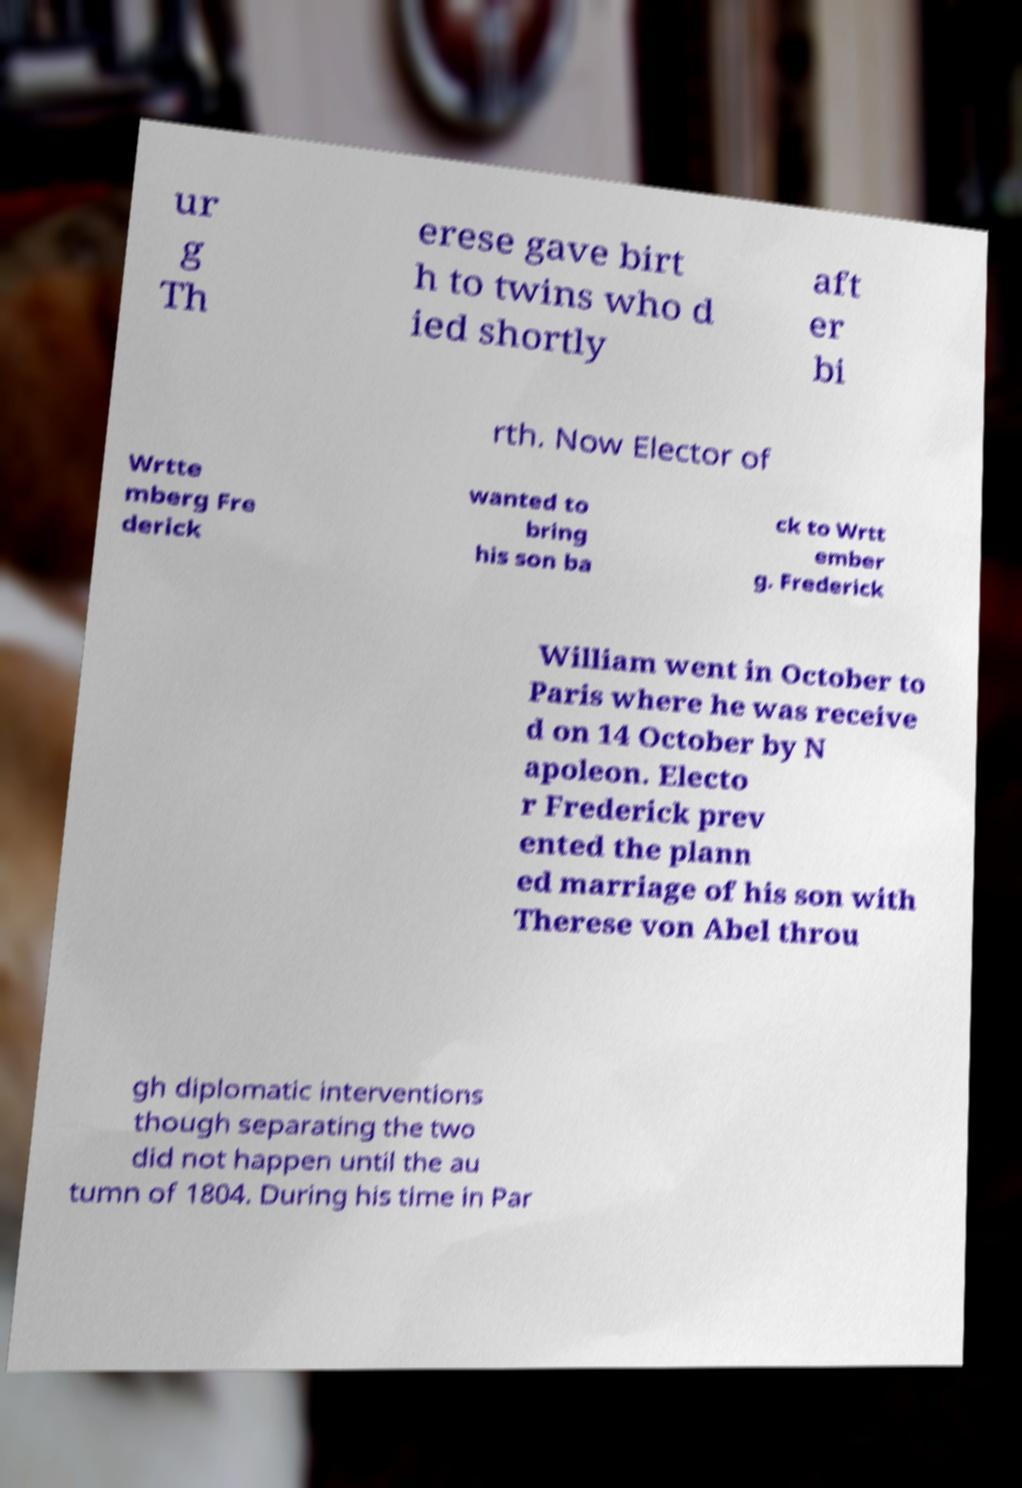Can you read and provide the text displayed in the image?This photo seems to have some interesting text. Can you extract and type it out for me? ur g Th erese gave birt h to twins who d ied shortly aft er bi rth. Now Elector of Wrtte mberg Fre derick wanted to bring his son ba ck to Wrtt ember g. Frederick William went in October to Paris where he was receive d on 14 October by N apoleon. Electo r Frederick prev ented the plann ed marriage of his son with Therese von Abel throu gh diplomatic interventions though separating the two did not happen until the au tumn of 1804. During his time in Par 